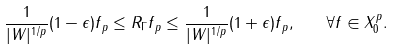Convert formula to latex. <formula><loc_0><loc_0><loc_500><loc_500>\frac { 1 } { | W | ^ { 1 / p } } ( 1 - \epsilon ) \| f \| _ { p } \leq \| R _ { \Gamma } f \| _ { p } \leq \frac { 1 } { | W | ^ { 1 / p } } ( 1 + \epsilon ) \| f \| _ { p } , \quad \forall f \in X _ { 0 } ^ { p } .</formula> 